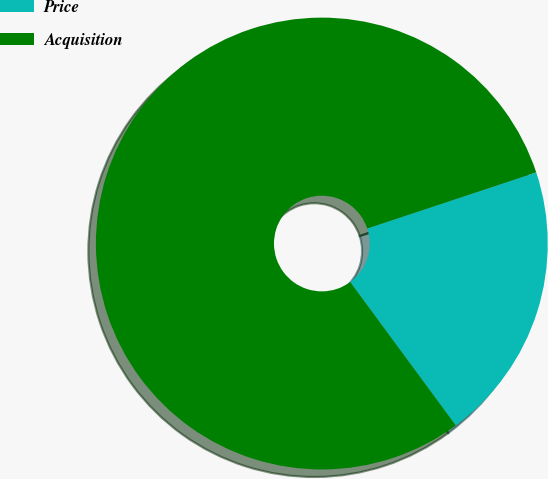Convert chart to OTSL. <chart><loc_0><loc_0><loc_500><loc_500><pie_chart><fcel>Price<fcel>Acquisition<nl><fcel>20.0%<fcel>80.0%<nl></chart> 